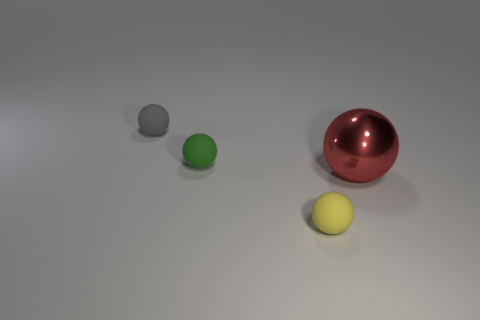Is there anything else that is the same material as the big thing?
Your answer should be compact. No. Is there a big red thing?
Offer a very short reply. Yes. What is the shape of the green rubber object that is behind the red ball?
Your answer should be compact. Sphere. How many things are right of the small yellow matte thing and behind the green rubber object?
Your answer should be very brief. 0. Are there any green cylinders that have the same material as the red object?
Give a very brief answer. No. How many cylinders are big objects or gray rubber things?
Keep it short and to the point. 0. The metal object is what size?
Provide a short and direct response. Large. How many shiny things are behind the gray thing?
Your answer should be very brief. 0. How big is the matte ball in front of the sphere that is right of the small yellow sphere?
Offer a terse response. Small. There is a tiny object on the right side of the small green thing; is it the same shape as the tiny rubber object that is behind the green rubber object?
Ensure brevity in your answer.  Yes. 